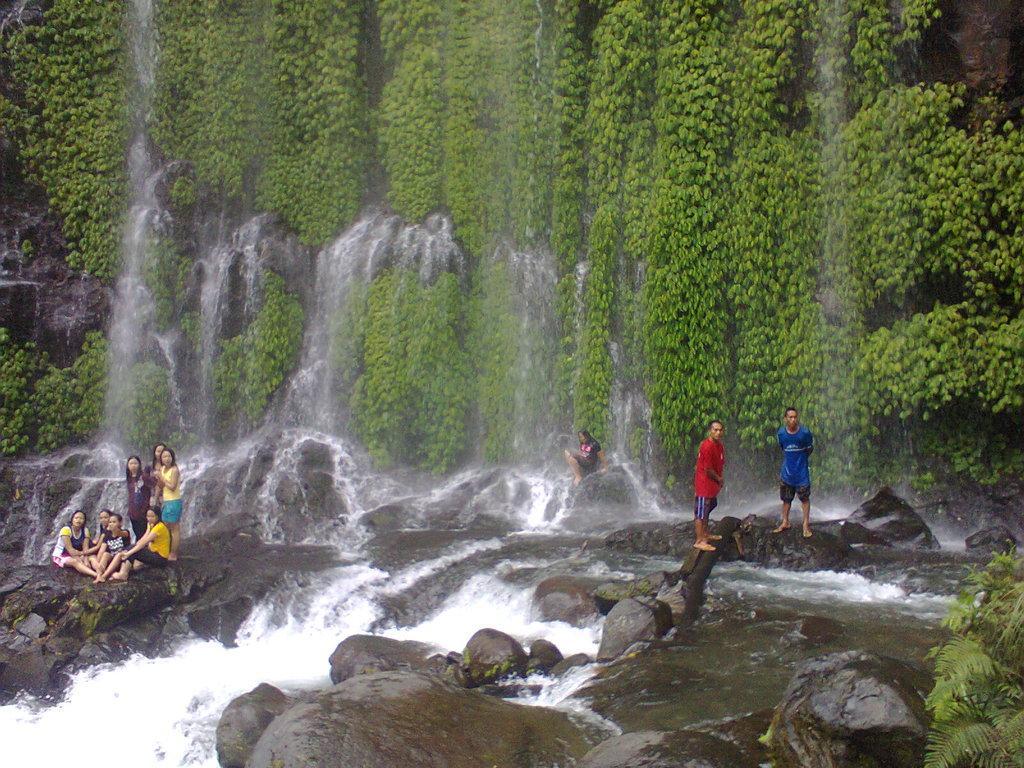How would you summarize this image in a sentence or two? In this image there are a few people sitting on the rocks and there are a few people standing. There is water flowing on the rocks. In the background of the image there are plants. 